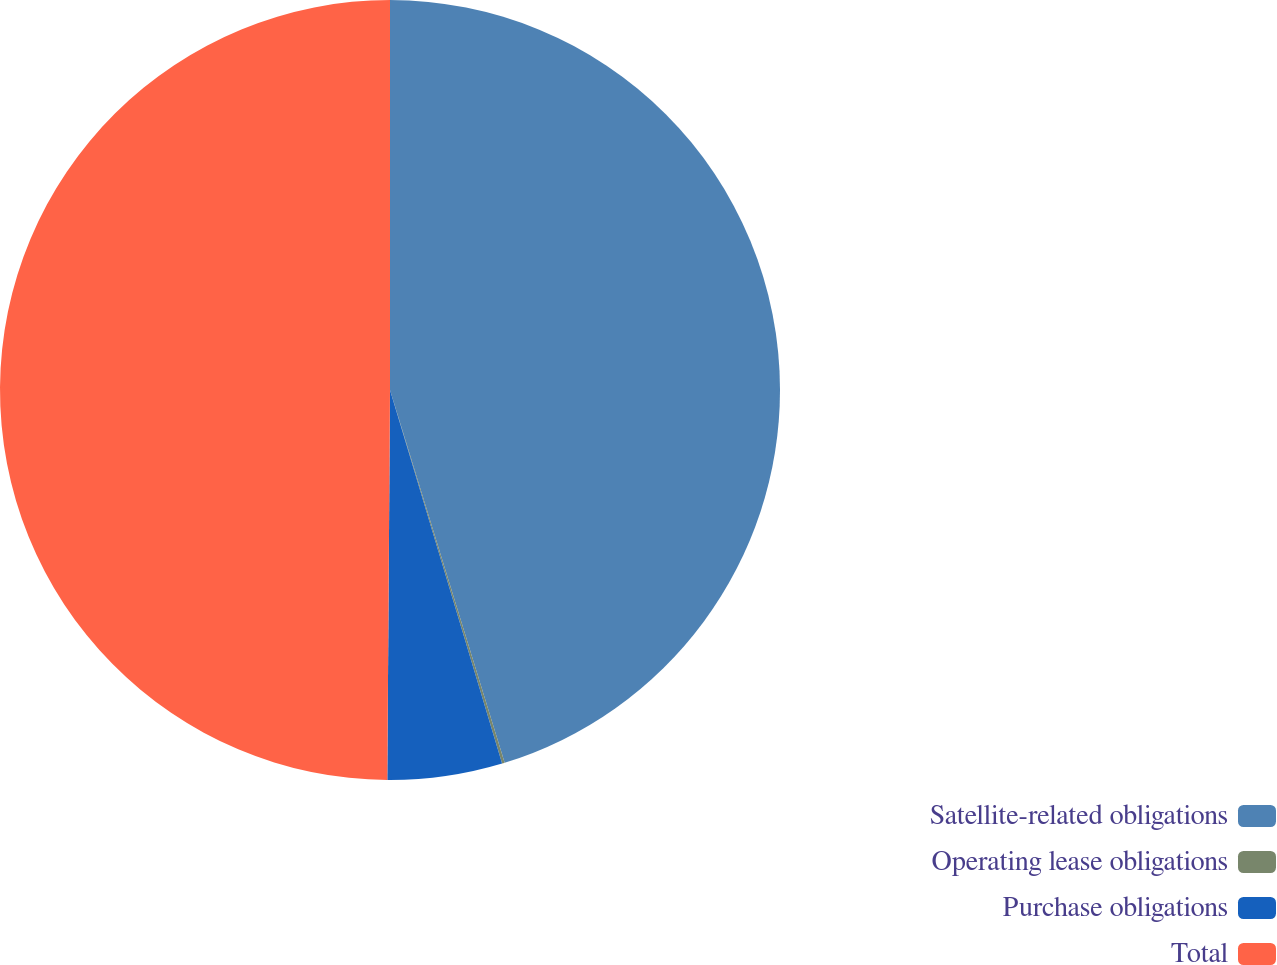Convert chart. <chart><loc_0><loc_0><loc_500><loc_500><pie_chart><fcel>Satellite-related obligations<fcel>Operating lease obligations<fcel>Purchase obligations<fcel>Total<nl><fcel>45.25%<fcel>0.11%<fcel>4.75%<fcel>49.89%<nl></chart> 